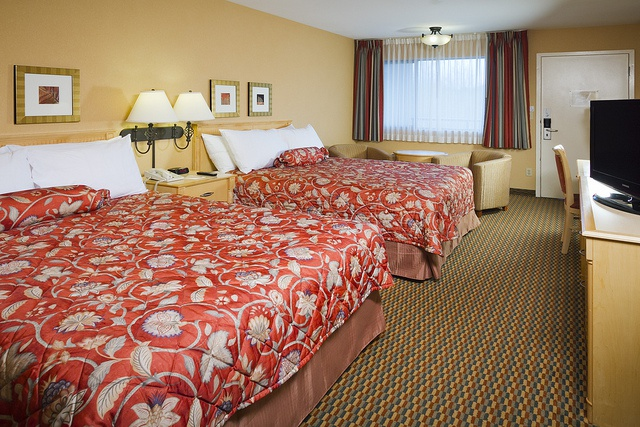Describe the objects in this image and their specific colors. I can see bed in olive, brown, lightgray, and darkgray tones, bed in olive, brown, lightgray, and darkgray tones, tv in olive, black, gray, and darkgray tones, chair in olive and tan tones, and chair in olive and maroon tones in this image. 